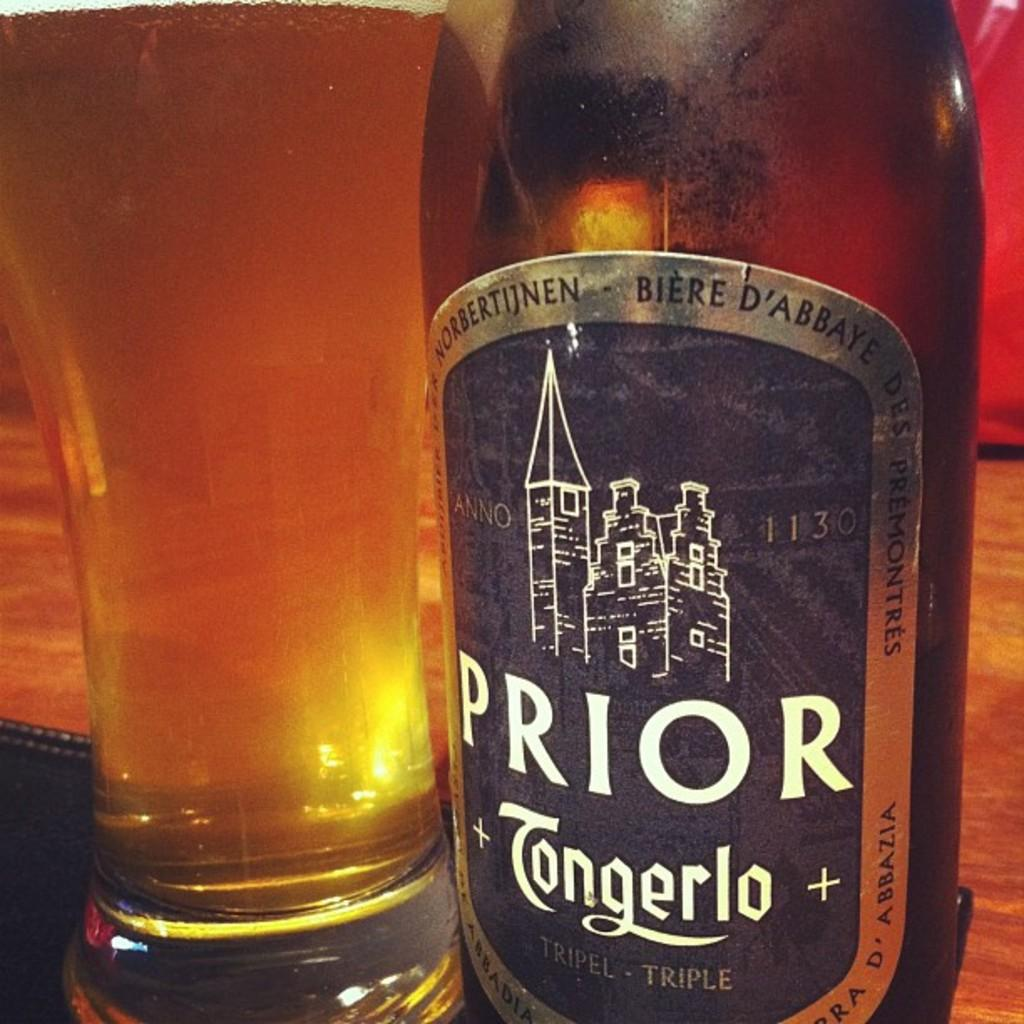<image>
Offer a succinct explanation of the picture presented. A glass bottle of Prior Tongerlo next to a drinking glass 